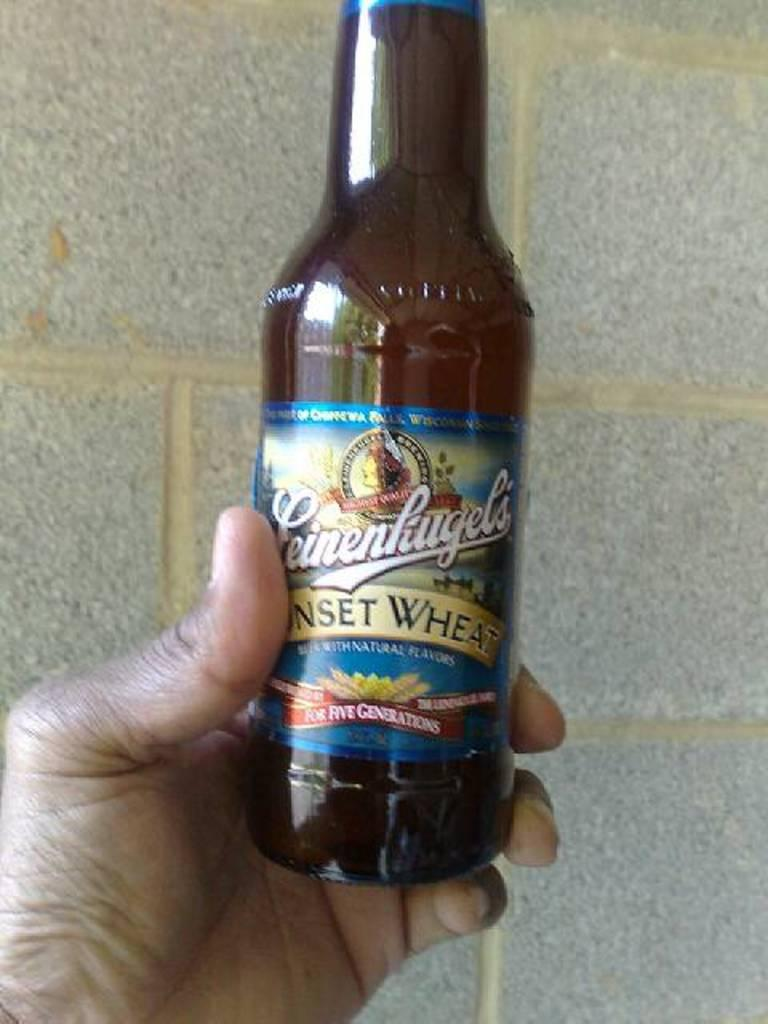<image>
Write a terse but informative summary of the picture. A brown beer bottle with a label that reads Sunset Wheat. 